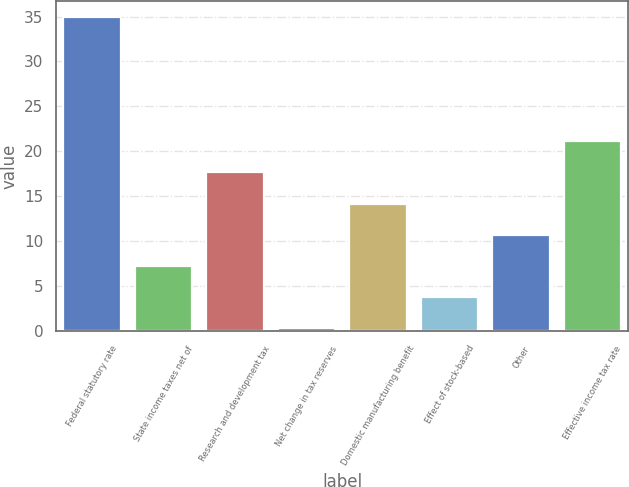Convert chart to OTSL. <chart><loc_0><loc_0><loc_500><loc_500><bar_chart><fcel>Federal statutory rate<fcel>State income taxes net of<fcel>Research and development tax<fcel>Net change in tax reserves<fcel>Domestic manufacturing benefit<fcel>Effect of stock-based<fcel>Other<fcel>Effective income tax rate<nl><fcel>35<fcel>7.24<fcel>17.65<fcel>0.3<fcel>14.18<fcel>3.77<fcel>10.71<fcel>21.12<nl></chart> 